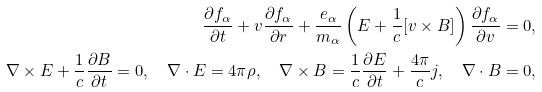<formula> <loc_0><loc_0><loc_500><loc_500>\frac { \partial f _ { \alpha } } { \partial t } + v \frac { \partial f _ { \alpha } } { \partial r } + \frac { e _ { \alpha } } { m _ { \alpha } } \left ( E + \frac { 1 } { c } [ v \times B ] \right ) \frac { \partial f _ { \alpha } } { \partial v } = 0 , \\ \nabla \times E + \frac { 1 } { c } \frac { \partial B } { \partial t } = 0 , \quad \nabla \cdot E = 4 \pi \rho , \quad \nabla \times B = \frac { 1 } { c } \frac { \partial E } { \partial t } + \frac { 4 \pi } { c } j , \quad \nabla \cdot B = 0 ,</formula> 